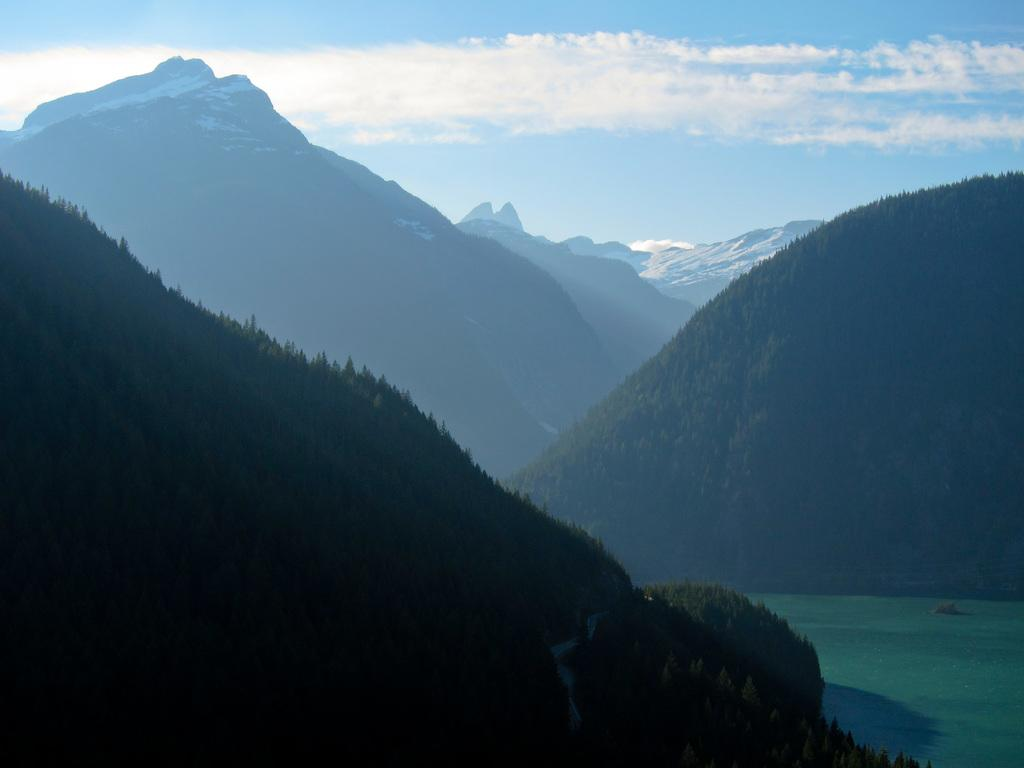What type of vegetation can be seen in the image? There are trees in the image. What natural element is visible in the image? There is water visible in the image. What type of geographical feature can be seen in the background of the image? There are mountains in the background of the image. What colors are present in the sky in the image? The sky is visible in the image, with a combination of white and blue colors. Can you see any veins in the image? There are no veins present in the image; it features natural elements such as trees, water, mountains, and the sky. 